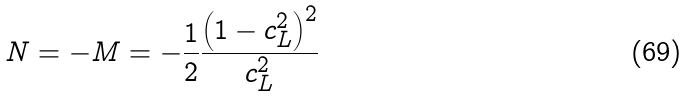Convert formula to latex. <formula><loc_0><loc_0><loc_500><loc_500>N = - M = - \frac { 1 } { 2 } \frac { \left ( 1 - c _ { L } ^ { 2 } \right ) ^ { 2 } } { c _ { L } ^ { 2 } }</formula> 